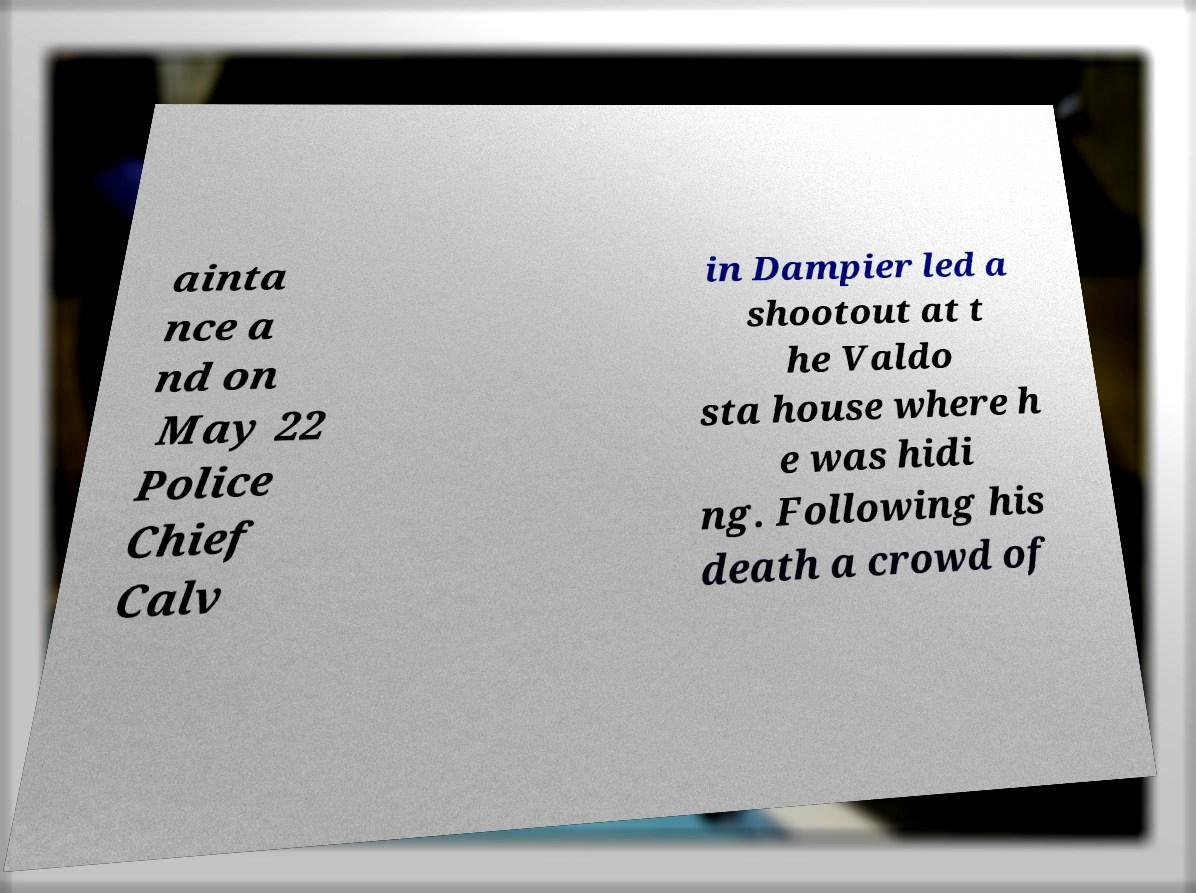What messages or text are displayed in this image? I need them in a readable, typed format. ainta nce a nd on May 22 Police Chief Calv in Dampier led a shootout at t he Valdo sta house where h e was hidi ng. Following his death a crowd of 